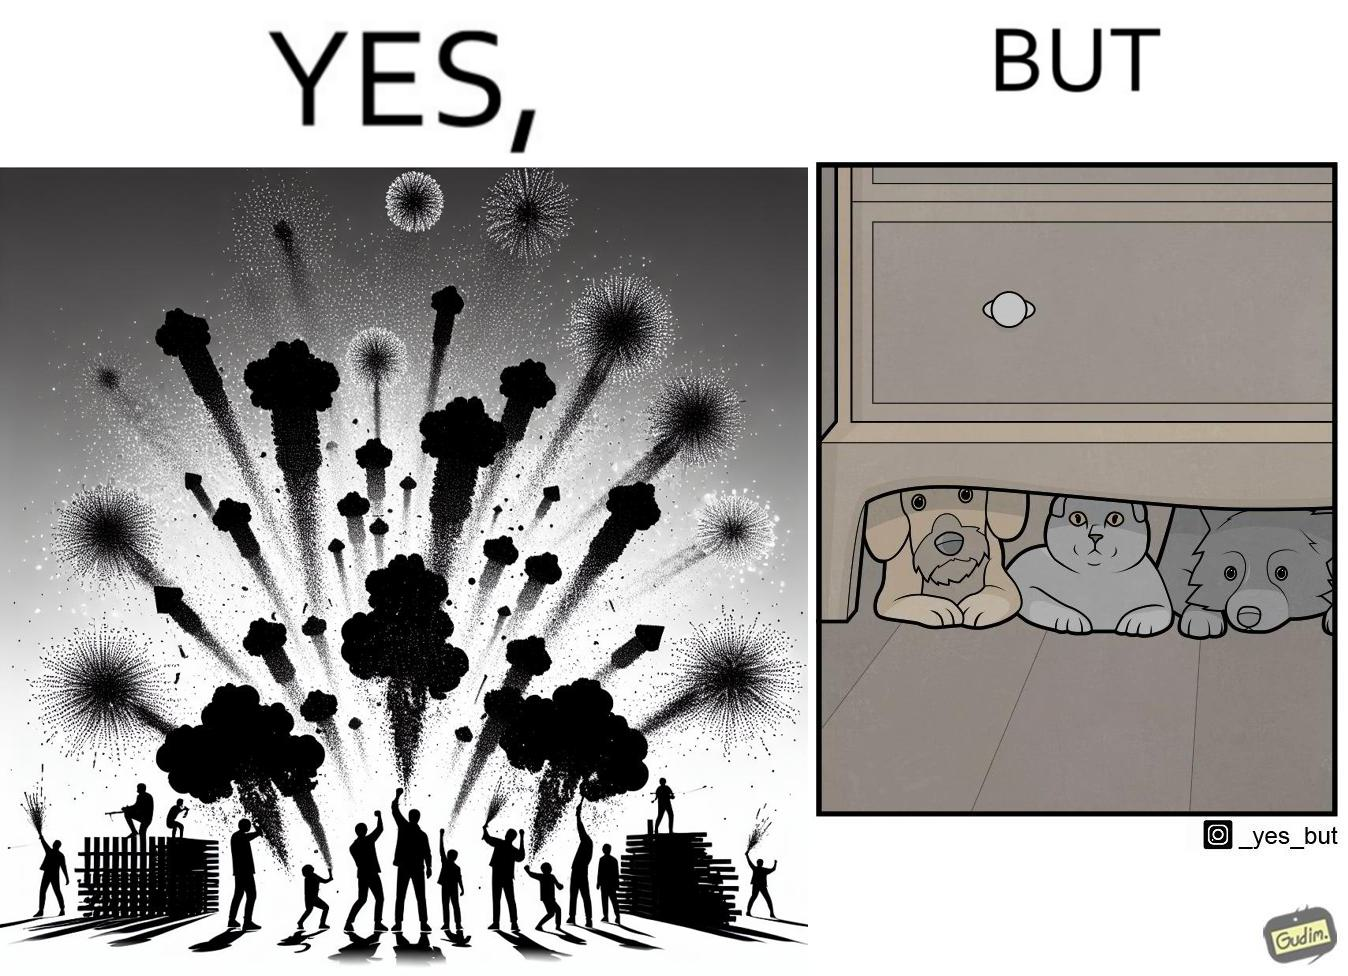What does this image depict? The image is satirical because while firecrackers in the sky look pretty, not everyone likes them. Animals are very scared of the firecrackers. 